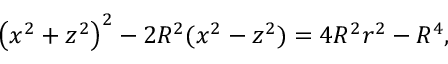Convert formula to latex. <formula><loc_0><loc_0><loc_500><loc_500>\left ( x ^ { 2 } + z ^ { 2 } \right ) ^ { 2 } - 2 R ^ { 2 } ( x ^ { 2 } - z ^ { 2 } ) = 4 R ^ { 2 } r ^ { 2 } - R ^ { 4 } ,</formula> 